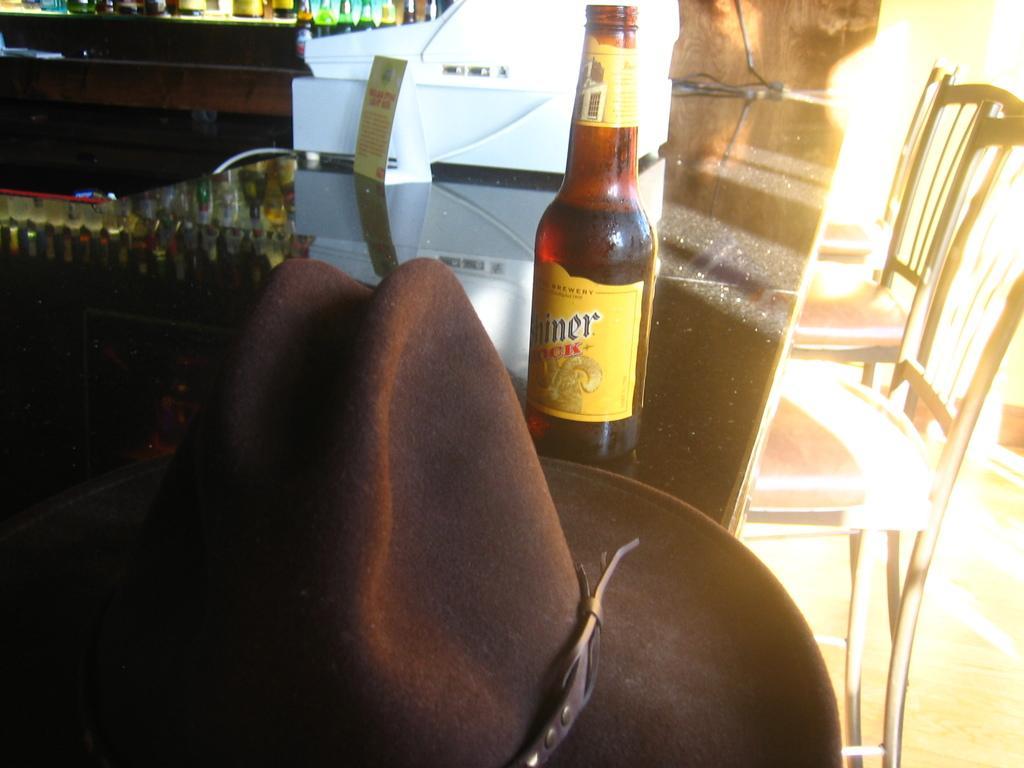Can you describe this image briefly? This picture might be taken inside a restaurant. In this image, on the right side, we can see some chairs and table. On that table, we can see a hat, wine bottle. On the left side, we can also see another table, on that table, we can see some bottles. 